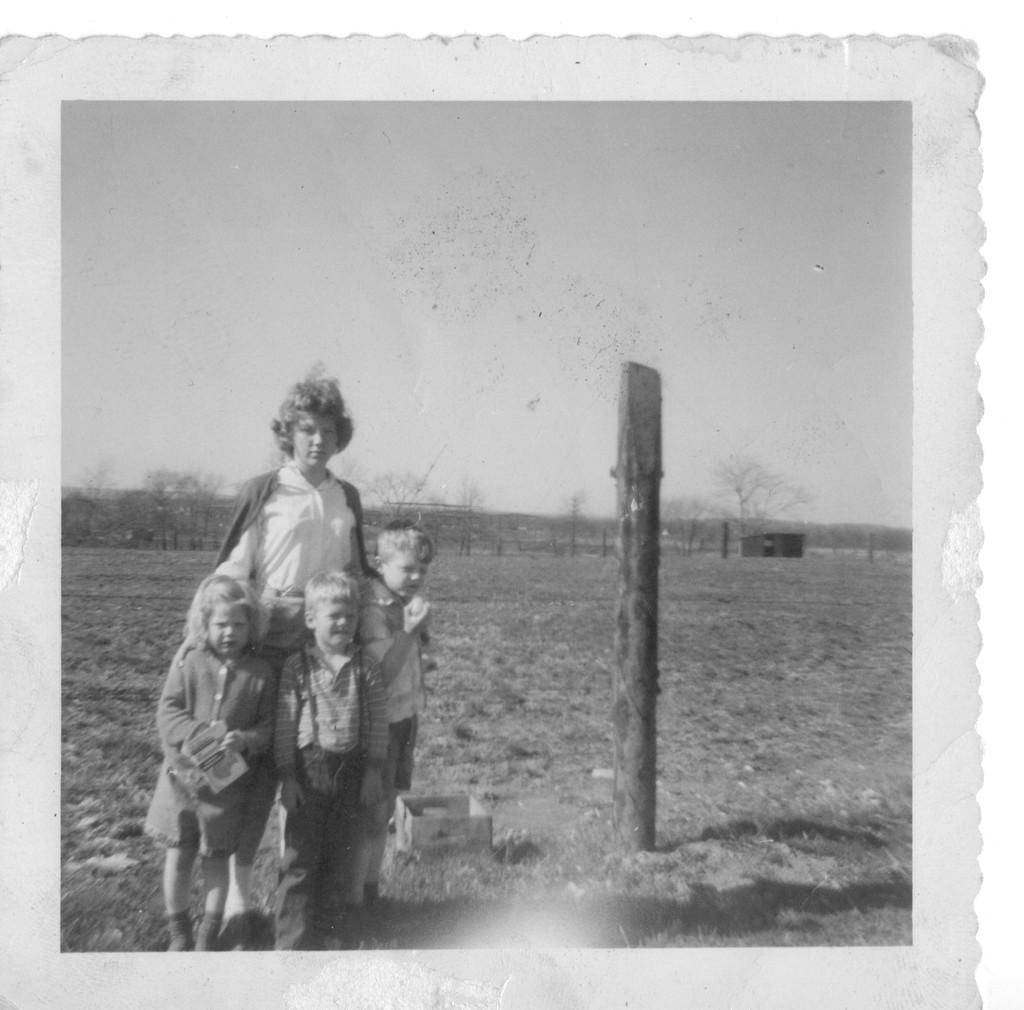Can you describe this image briefly? This is a black and white pic. We can see photograph on a platform. In the photograph we can see few persons are standing on the ground and there is a carton box and pole. In the background we can see a house, trees and sky. 